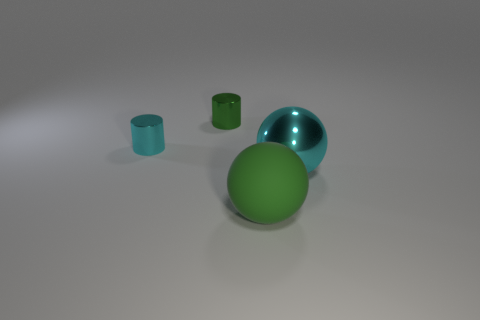The cyan metallic thing that is behind the large thing behind the green ball is what shape?
Ensure brevity in your answer.  Cylinder. Are there fewer brown rubber things than big green objects?
Ensure brevity in your answer.  Yes. What color is the matte sphere that is in front of the cyan metallic sphere?
Give a very brief answer. Green. There is a object that is behind the rubber thing and right of the small green thing; what material is it?
Give a very brief answer. Metal. There is a big object that is the same material as the small cyan object; what is its shape?
Ensure brevity in your answer.  Sphere. What number of big metal spheres are to the left of the metal cylinder in front of the small green metal cylinder?
Your response must be concise. 0. How many objects are both behind the big green rubber ball and right of the small green shiny thing?
Provide a succinct answer. 1. What number of other things are there of the same material as the green sphere
Offer a very short reply. 0. What is the color of the object in front of the thing on the right side of the big green rubber sphere?
Ensure brevity in your answer.  Green. Is the color of the shiny thing on the right side of the green cylinder the same as the rubber thing?
Keep it short and to the point. No. 